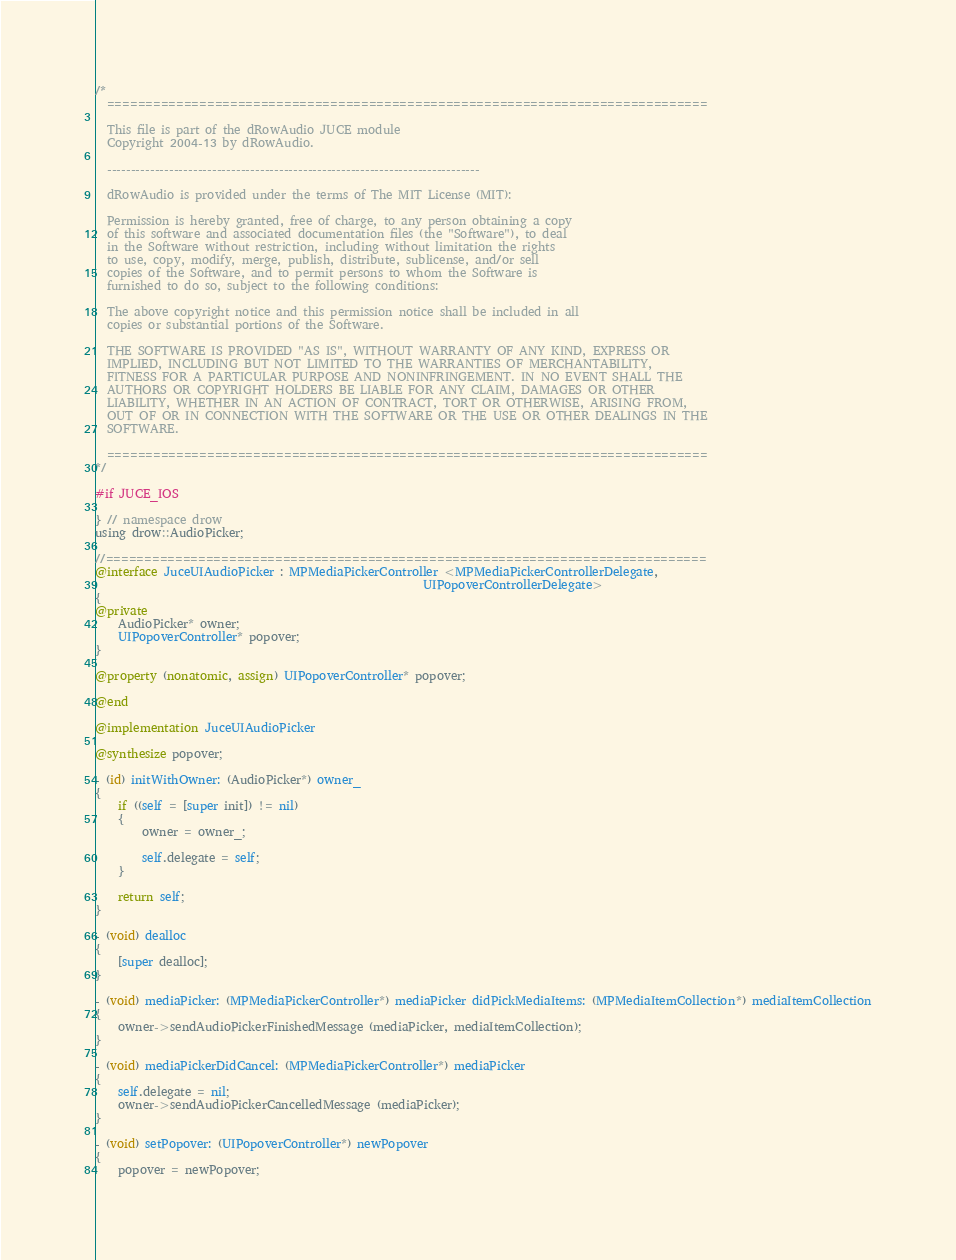Convert code to text. <code><loc_0><loc_0><loc_500><loc_500><_ObjectiveC_>/*
  ==============================================================================

  This file is part of the dRowAudio JUCE module
  Copyright 2004-13 by dRowAudio.

  ------------------------------------------------------------------------------

  dRowAudio is provided under the terms of The MIT License (MIT):

  Permission is hereby granted, free of charge, to any person obtaining a copy
  of this software and associated documentation files (the "Software"), to deal
  in the Software without restriction, including without limitation the rights
  to use, copy, modify, merge, publish, distribute, sublicense, and/or sell
  copies of the Software, and to permit persons to whom the Software is
  furnished to do so, subject to the following conditions:

  The above copyright notice and this permission notice shall be included in all
  copies or substantial portions of the Software.

  THE SOFTWARE IS PROVIDED "AS IS", WITHOUT WARRANTY OF ANY KIND, EXPRESS OR
  IMPLIED, INCLUDING BUT NOT LIMITED TO THE WARRANTIES OF MERCHANTABILITY, 
  FITNESS FOR A PARTICULAR PURPOSE AND NONINFRINGEMENT. IN NO EVENT SHALL THE 
  AUTHORS OR COPYRIGHT HOLDERS BE LIABLE FOR ANY CLAIM, DAMAGES OR OTHER 
  LIABILITY, WHETHER IN AN ACTION OF CONTRACT, TORT OR OTHERWISE, ARISING FROM,
  OUT OF OR IN CONNECTION WITH THE SOFTWARE OR THE USE OR OTHER DEALINGS IN THE 
  SOFTWARE.

  ==============================================================================
*/

#if JUCE_IOS

} // namespace drow
using drow::AudioPicker;

//==============================================================================
@interface JuceUIAudioPicker : MPMediaPickerController <MPMediaPickerControllerDelegate,
                                                        UIPopoverControllerDelegate>
{
@private
    AudioPicker* owner;
    UIPopoverController* popover;
}

@property (nonatomic, assign) UIPopoverController* popover;

@end

@implementation JuceUIAudioPicker

@synthesize popover;

- (id) initWithOwner: (AudioPicker*) owner_
{
    if ((self = [super init]) != nil)
    {
        owner = owner_;

        self.delegate = self;
    }
    
    return self;
}

- (void) dealloc
{
    [super dealloc];
}

- (void) mediaPicker: (MPMediaPickerController*) mediaPicker didPickMediaItems: (MPMediaItemCollection*) mediaItemCollection
{
    owner->sendAudioPickerFinishedMessage (mediaPicker, mediaItemCollection);
}

- (void) mediaPickerDidCancel: (MPMediaPickerController*) mediaPicker
{
    self.delegate = nil;
    owner->sendAudioPickerCancelledMessage (mediaPicker);
}

- (void) setPopover: (UIPopoverController*) newPopover
{
    popover = newPopover;</code> 